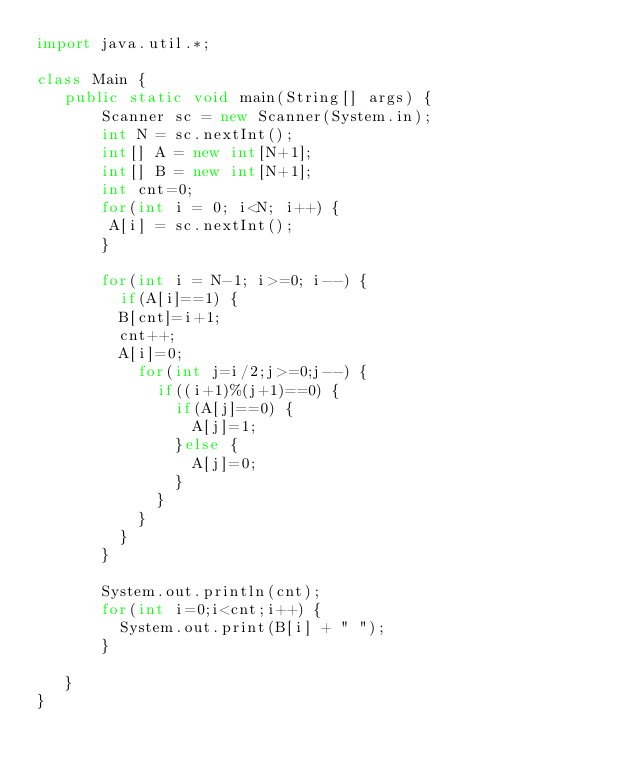<code> <loc_0><loc_0><loc_500><loc_500><_Java_>import java.util.*;

class Main {
   public static void main(String[] args) {
       Scanner sc = new Scanner(System.in);
       int N = sc.nextInt();
       int[] A = new int[N+1];
       int[] B = new int[N+1];
       int cnt=0;
       for(int i = 0; i<N; i++) {
       	A[i] = sc.nextInt();
       }
       
       for(int i = N-1; i>=0; i--) {
    	   if(A[i]==1) {
			   B[cnt]=i+1;
			   cnt++;
			   A[i]=0;
    		   for(int j=i/2;j>=0;j--) {
    			   if((i+1)%(j+1)==0) {
    				   if(A[j]==0) {
    					   A[j]=1;
    				   }else {
    					   A[j]=0;
    				   }
    			   }
    		   }
    	   }
       }
       
       System.out.println(cnt);
       for(int i=0;i<cnt;i++) {
    	   System.out.print(B[i] + " ");
       }
       
   }
}</code> 